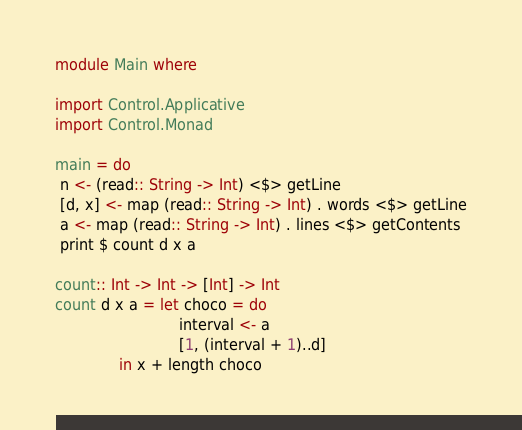Convert code to text. <code><loc_0><loc_0><loc_500><loc_500><_Haskell_>module Main where

import Control.Applicative
import Control.Monad

main = do
 n <- (read:: String -> Int) <$> getLine
 [d, x] <- map (read:: String -> Int) . words <$> getLine
 a <- map (read:: String -> Int) . lines <$> getContents
 print $ count d x a

count:: Int -> Int -> [Int] -> Int
count d x a = let choco = do
                           interval <- a
                           [1, (interval + 1)..d]
              in x + length choco

</code> 